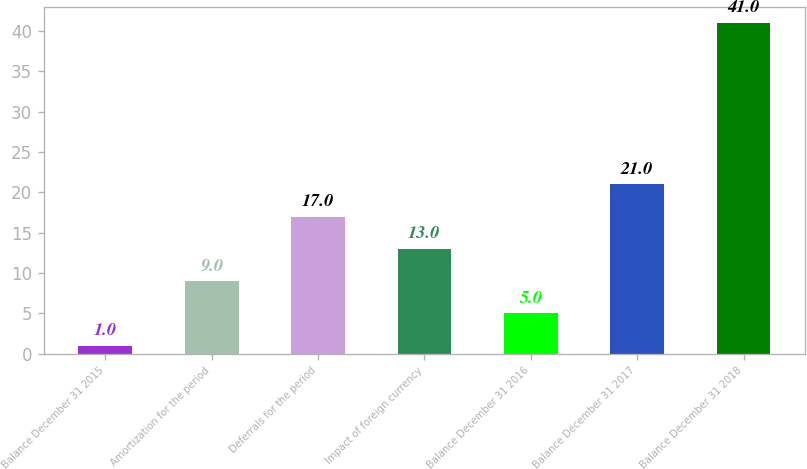Convert chart to OTSL. <chart><loc_0><loc_0><loc_500><loc_500><bar_chart><fcel>Balance December 31 2015<fcel>Amortization for the period<fcel>Deferrals for the period<fcel>Impact of foreign currency<fcel>Balance December 31 2016<fcel>Balance December 31 2017<fcel>Balance December 31 2018<nl><fcel>1<fcel>9<fcel>17<fcel>13<fcel>5<fcel>21<fcel>41<nl></chart> 